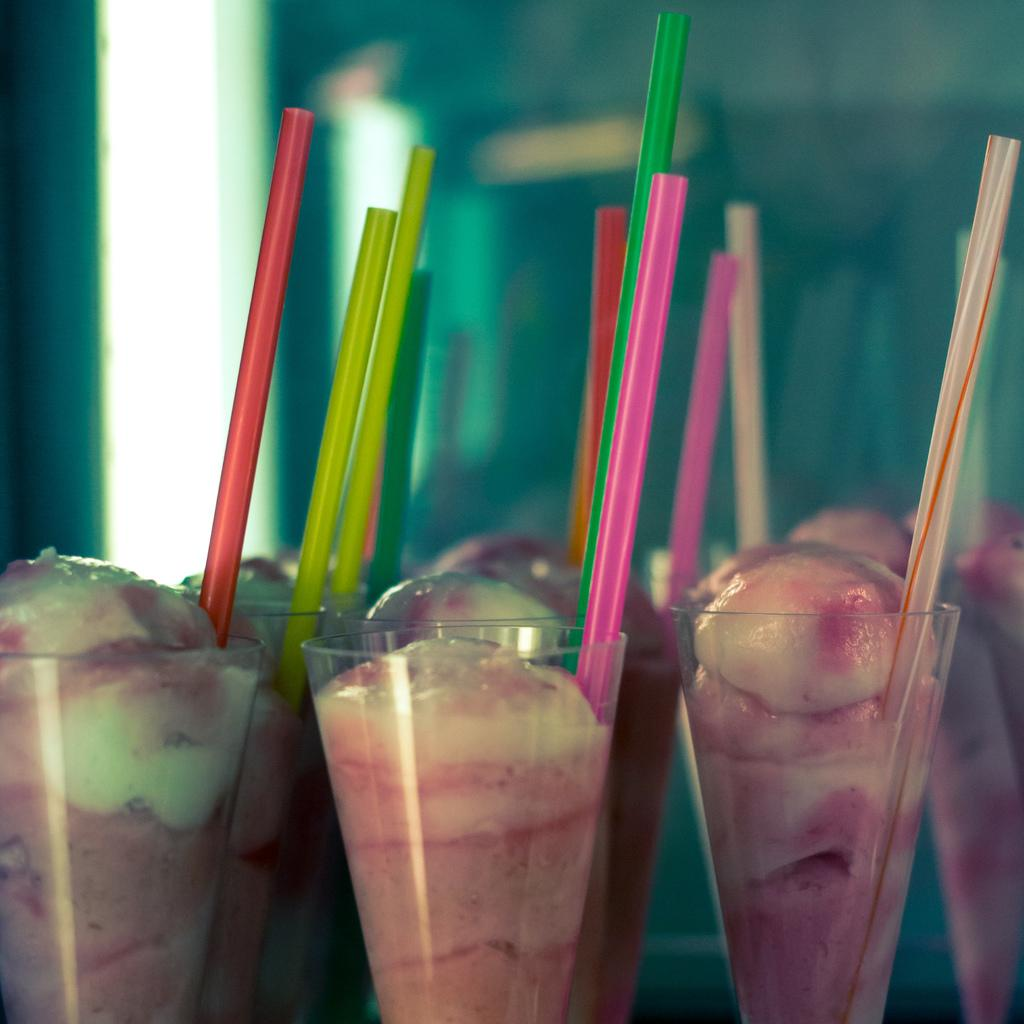What types of objects can be seen in the image? There are food items and straws in glasses in the image. Can you describe the glasses in the image? The glasses have straws in them. What can be observed about the background of the image? The background of the image is blurred. How many cacti are present in the image? There are no cacti present in the image. What type of fairies can be seen interacting with the food items in the image? There are no fairies present in the image. 